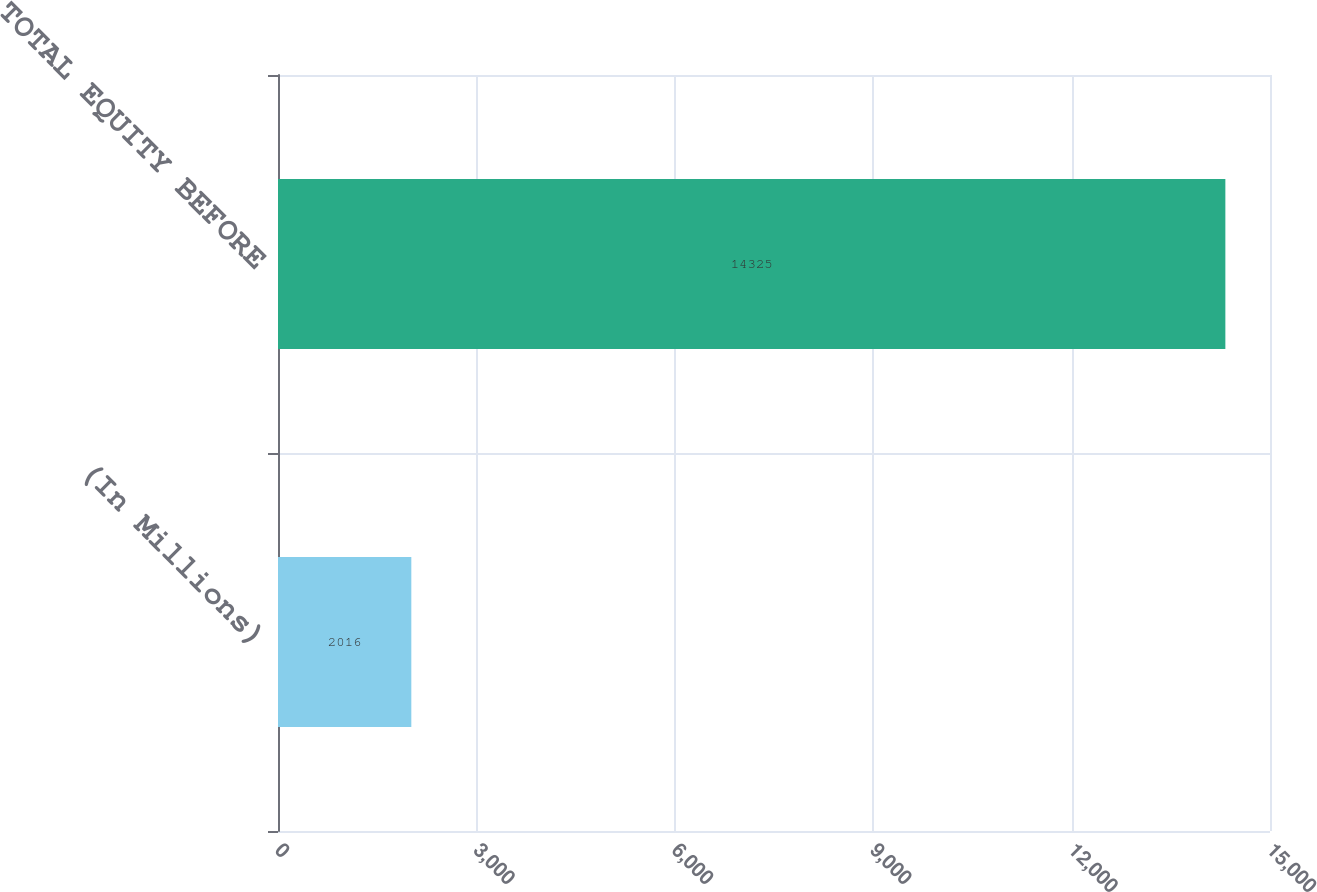Convert chart to OTSL. <chart><loc_0><loc_0><loc_500><loc_500><bar_chart><fcel>(In Millions)<fcel>TOTAL EQUITY BEFORE<nl><fcel>2016<fcel>14325<nl></chart> 